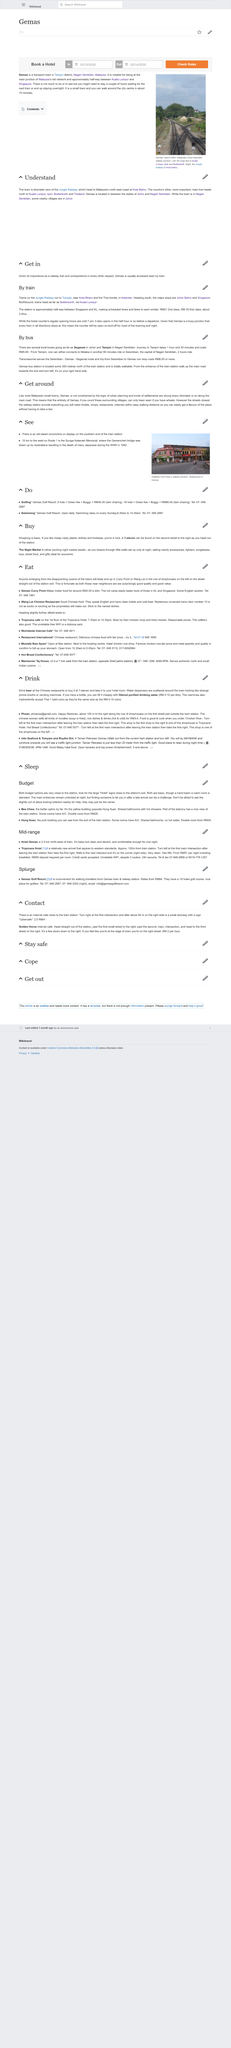List a handful of essential elements in this visual. Yes, both Phuan and Udo Seafood and Tomyam and RoyAin Ent are places where food can be purchased. The regular ticket counter opening hours at Gemas rail station end at 7pm. Yes, it is possible for beer to be consumed at Chinese restaurants. The cost of filtered and purified drinking water is RM 0.10 per litre. The minimum cost to travel by bus from Seremban to Gemas non-stop is RM8.50. 